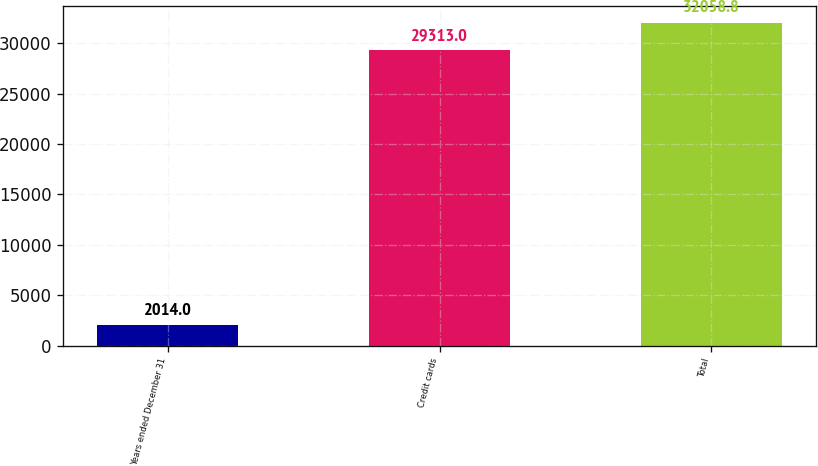<chart> <loc_0><loc_0><loc_500><loc_500><bar_chart><fcel>Years ended December 31<fcel>Credit cards<fcel>Total<nl><fcel>2014<fcel>29313<fcel>32058.8<nl></chart> 